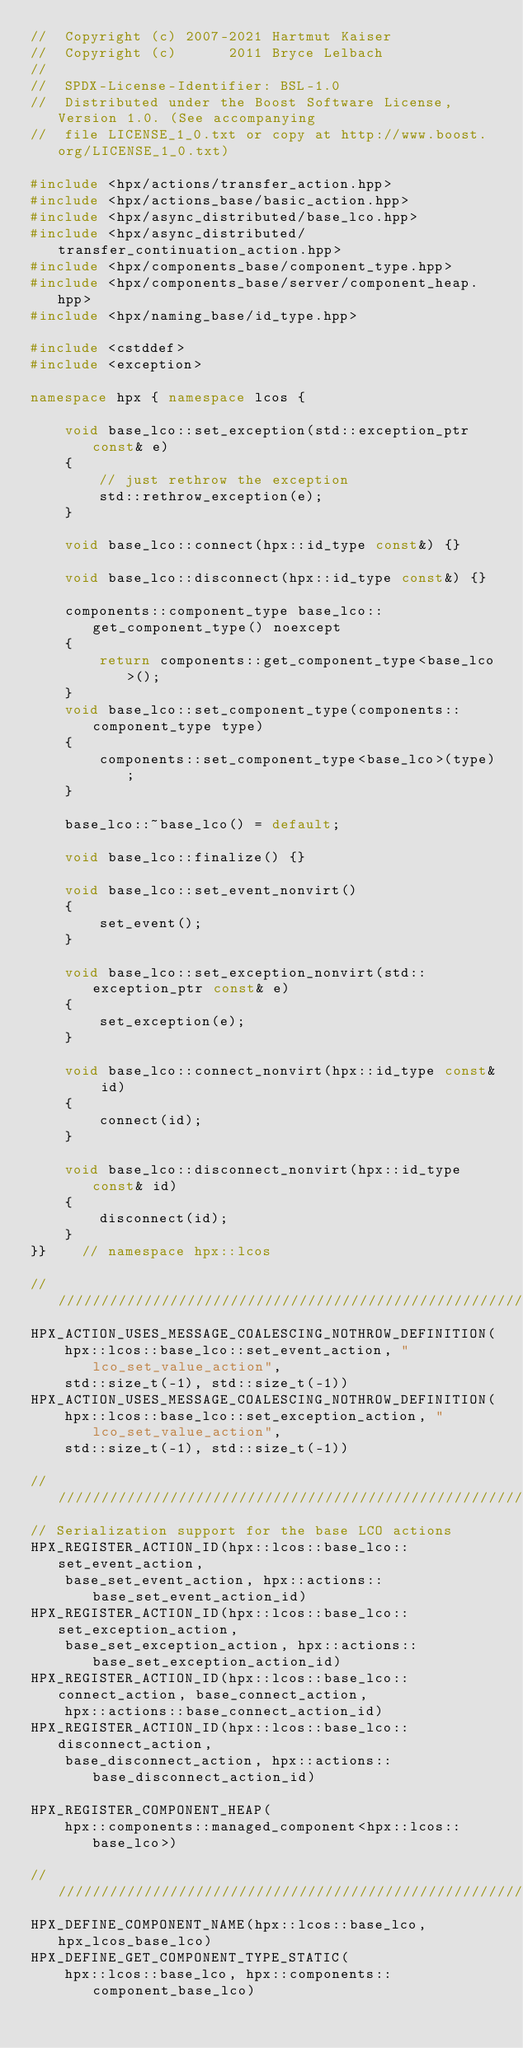Convert code to text. <code><loc_0><loc_0><loc_500><loc_500><_C++_>//  Copyright (c) 2007-2021 Hartmut Kaiser
//  Copyright (c)      2011 Bryce Lelbach
//
//  SPDX-License-Identifier: BSL-1.0
//  Distributed under the Boost Software License, Version 1.0. (See accompanying
//  file LICENSE_1_0.txt or copy at http://www.boost.org/LICENSE_1_0.txt)

#include <hpx/actions/transfer_action.hpp>
#include <hpx/actions_base/basic_action.hpp>
#include <hpx/async_distributed/base_lco.hpp>
#include <hpx/async_distributed/transfer_continuation_action.hpp>
#include <hpx/components_base/component_type.hpp>
#include <hpx/components_base/server/component_heap.hpp>
#include <hpx/naming_base/id_type.hpp>

#include <cstddef>
#include <exception>

namespace hpx { namespace lcos {

    void base_lco::set_exception(std::exception_ptr const& e)
    {
        // just rethrow the exception
        std::rethrow_exception(e);
    }

    void base_lco::connect(hpx::id_type const&) {}

    void base_lco::disconnect(hpx::id_type const&) {}

    components::component_type base_lco::get_component_type() noexcept
    {
        return components::get_component_type<base_lco>();
    }
    void base_lco::set_component_type(components::component_type type)
    {
        components::set_component_type<base_lco>(type);
    }

    base_lco::~base_lco() = default;

    void base_lco::finalize() {}

    void base_lco::set_event_nonvirt()
    {
        set_event();
    }

    void base_lco::set_exception_nonvirt(std::exception_ptr const& e)
    {
        set_exception(e);
    }

    void base_lco::connect_nonvirt(hpx::id_type const& id)
    {
        connect(id);
    }

    void base_lco::disconnect_nonvirt(hpx::id_type const& id)
    {
        disconnect(id);
    }
}}    // namespace hpx::lcos

///////////////////////////////////////////////////////////////////////////////
HPX_ACTION_USES_MESSAGE_COALESCING_NOTHROW_DEFINITION(
    hpx::lcos::base_lco::set_event_action, "lco_set_value_action",
    std::size_t(-1), std::size_t(-1))
HPX_ACTION_USES_MESSAGE_COALESCING_NOTHROW_DEFINITION(
    hpx::lcos::base_lco::set_exception_action, "lco_set_value_action",
    std::size_t(-1), std::size_t(-1))

///////////////////////////////////////////////////////////////////////////////
// Serialization support for the base LCO actions
HPX_REGISTER_ACTION_ID(hpx::lcos::base_lco::set_event_action,
    base_set_event_action, hpx::actions::base_set_event_action_id)
HPX_REGISTER_ACTION_ID(hpx::lcos::base_lco::set_exception_action,
    base_set_exception_action, hpx::actions::base_set_exception_action_id)
HPX_REGISTER_ACTION_ID(hpx::lcos::base_lco::connect_action, base_connect_action,
    hpx::actions::base_connect_action_id)
HPX_REGISTER_ACTION_ID(hpx::lcos::base_lco::disconnect_action,
    base_disconnect_action, hpx::actions::base_disconnect_action_id)

HPX_REGISTER_COMPONENT_HEAP(
    hpx::components::managed_component<hpx::lcos::base_lco>)

///////////////////////////////////////////////////////////////////////////////
HPX_DEFINE_COMPONENT_NAME(hpx::lcos::base_lco, hpx_lcos_base_lco)
HPX_DEFINE_GET_COMPONENT_TYPE_STATIC(
    hpx::lcos::base_lco, hpx::components::component_base_lco)
</code> 